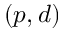Convert formula to latex. <formula><loc_0><loc_0><loc_500><loc_500>( p , d )</formula> 